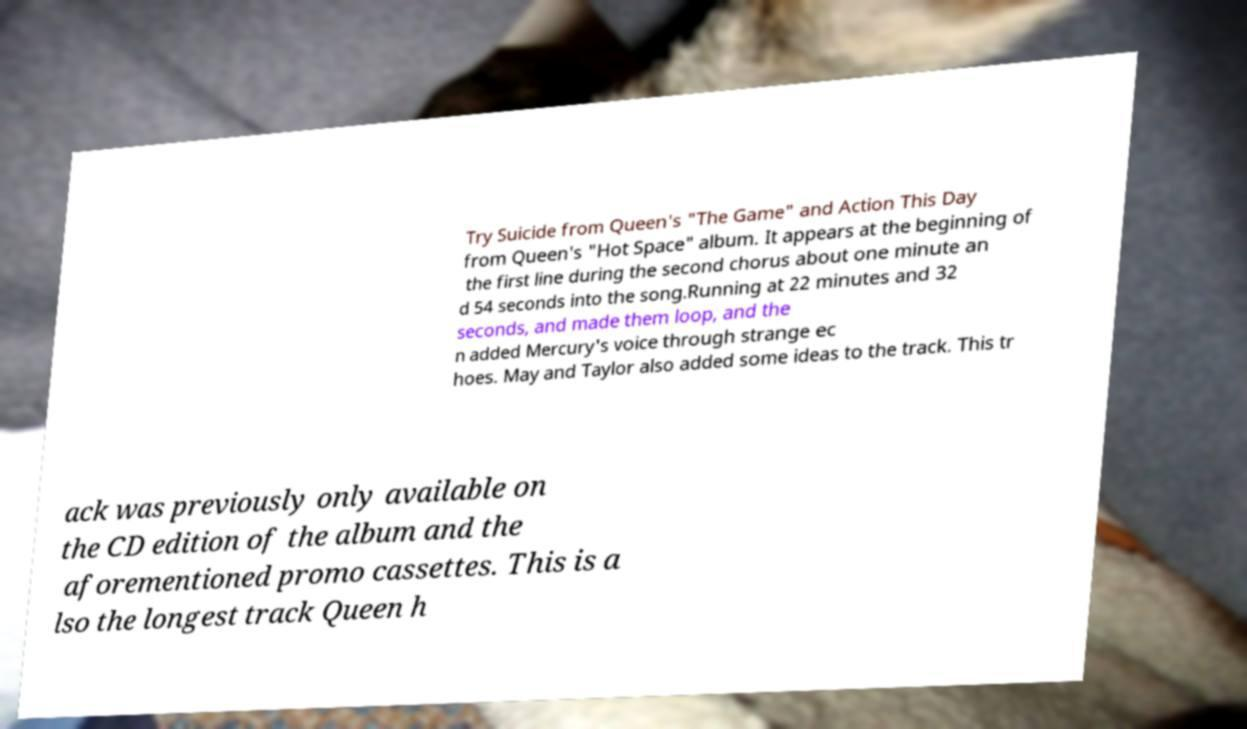Can you accurately transcribe the text from the provided image for me? Try Suicide from Queen's "The Game" and Action This Day from Queen's "Hot Space" album. It appears at the beginning of the first line during the second chorus about one minute an d 54 seconds into the song.Running at 22 minutes and 32 seconds, and made them loop, and the n added Mercury's voice through strange ec hoes. May and Taylor also added some ideas to the track. This tr ack was previously only available on the CD edition of the album and the aforementioned promo cassettes. This is a lso the longest track Queen h 